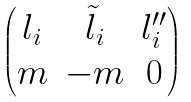Convert formula to latex. <formula><loc_0><loc_0><loc_500><loc_500>\begin{pmatrix} l _ { i } & \tilde { l } _ { i } & l _ { i } ^ { \prime \prime } \\ m & - m & 0 \end{pmatrix}</formula> 